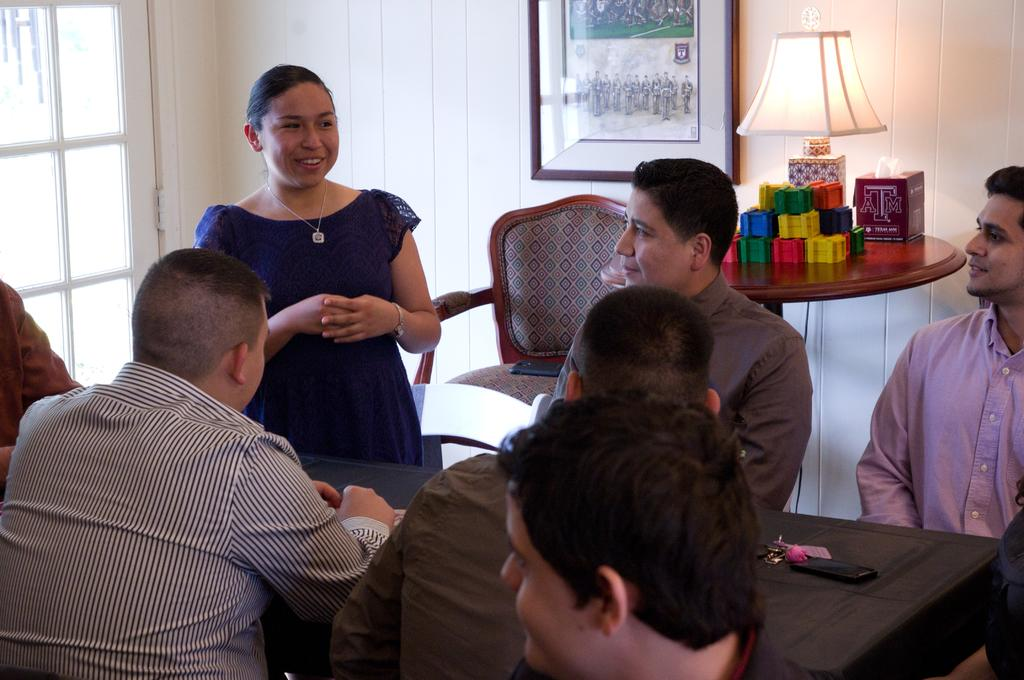What are the people in the image doing? There is a group of people sitting on chairs in the image. What is located in front of the chairs? The chairs are in front of a table. What is the woman in the image doing? The woman is standing in the image. What expression does the woman have? The woman is smiling. What type of gold thread is the woman using to stitch the school uniform in the image? There is no gold thread, school, or uniform present in the image. The woman is simply standing and smiling. 